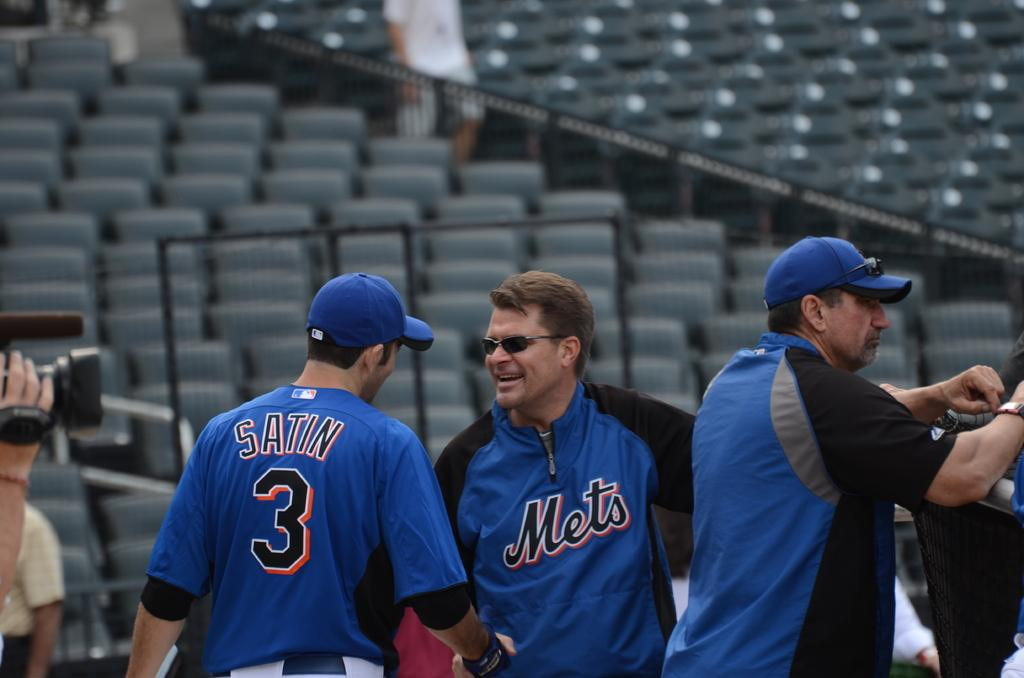<image>
Render a clear and concise summary of the photo. A man wearing a Mets jacket talks to a man wearing the number 3 jersey. 